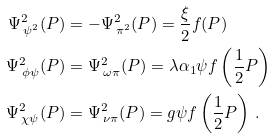<formula> <loc_0><loc_0><loc_500><loc_500>\Psi ^ { 2 } _ { \, \psi ^ { 2 } } ( P ) & = - \Psi ^ { 2 } _ { \, \pi ^ { 2 } } ( P ) = \frac { \xi } { 2 } f ( P ) \\ \Psi ^ { 2 } _ { \, \phi \psi } ( P ) & = \Psi ^ { 2 } _ { \, \omega \pi } ( P ) = \lambda \alpha _ { 1 } \psi f \left ( \frac { 1 } { 2 } P \right ) \\ \Psi ^ { 2 } _ { \, \chi \psi } ( P ) & = \Psi ^ { 2 } _ { \, \nu \pi } ( P ) = g \psi f \left ( \frac { 1 } { 2 } P \right ) \, .</formula> 